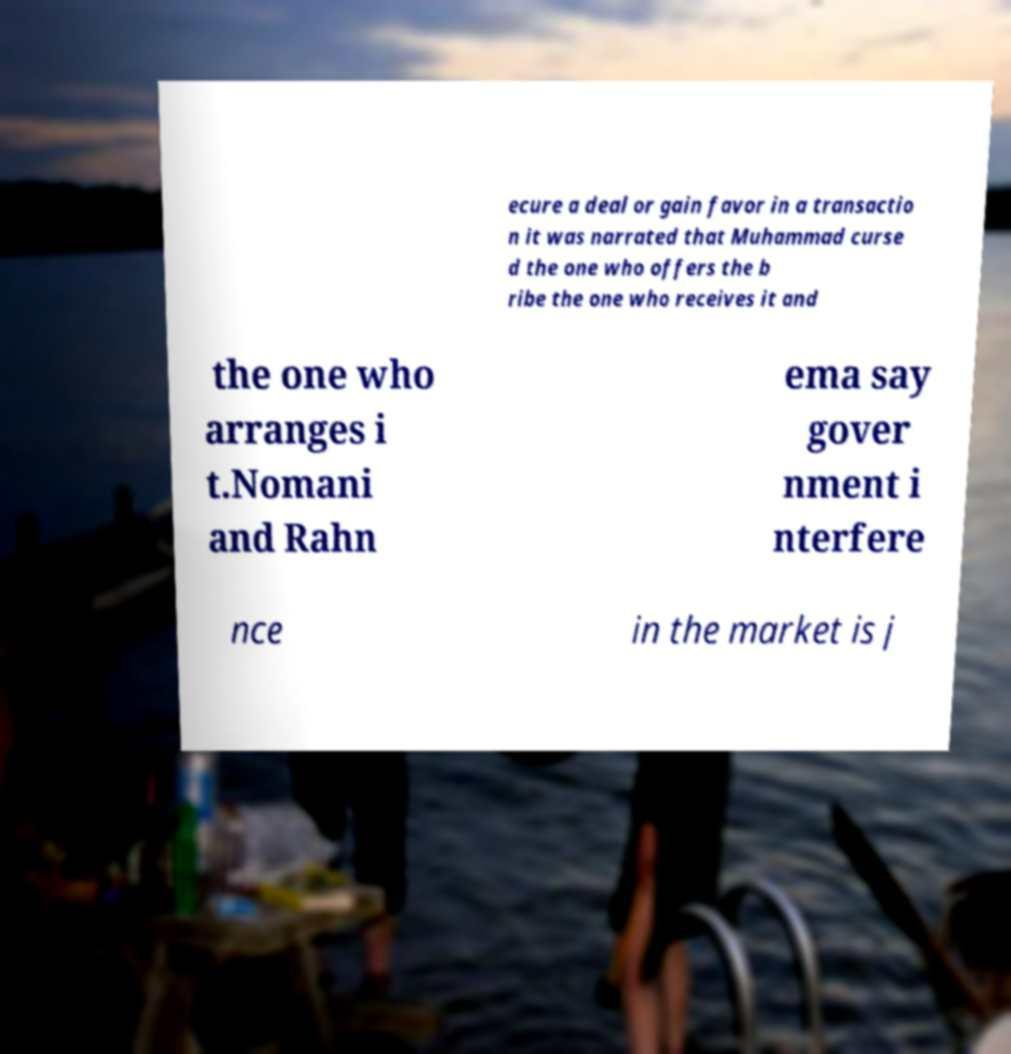What messages or text are displayed in this image? I need them in a readable, typed format. ecure a deal or gain favor in a transactio n it was narrated that Muhammad curse d the one who offers the b ribe the one who receives it and the one who arranges i t.Nomani and Rahn ema say gover nment i nterfere nce in the market is j 